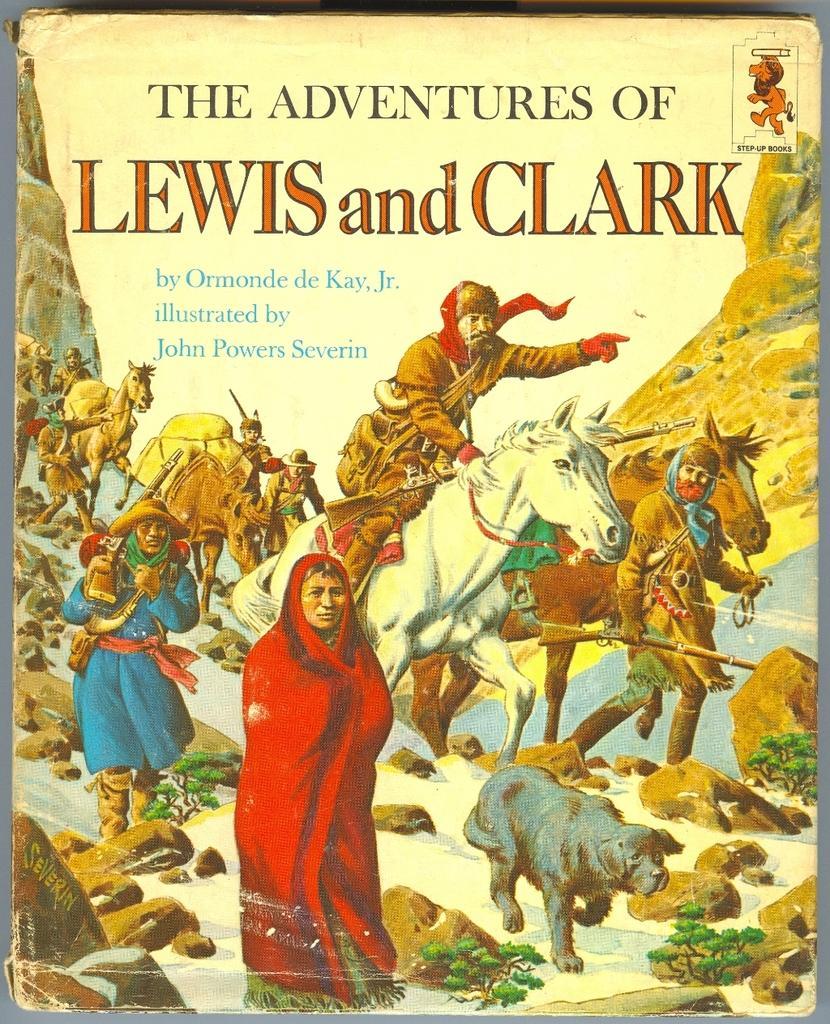Please provide a concise description of this image. In the image we can see the front page of the book, in it we can see the people wearing clothes and animals. We can even see the stones, grass, water and the hills. We can even see the text. 